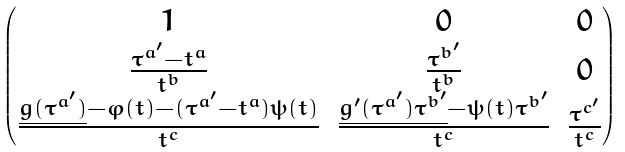Convert formula to latex. <formula><loc_0><loc_0><loc_500><loc_500>\begin{pmatrix} 1 & 0 & 0 \\ \frac { \tau ^ { a ^ { \prime } } - t ^ { a } } { t ^ { b } } & \frac { \tau ^ { b ^ { \prime } } } { t ^ { b } } & 0 \\ \frac { \underline { g ( \tau ^ { a ^ { \prime } } ) } - \varphi ( t ) - ( \tau ^ { a ^ { \prime } } - t ^ { a } ) \psi ( t ) } { t ^ { c } } & \frac { \underline { g ^ { \prime } ( \tau ^ { a ^ { \prime } } ) \tau ^ { b ^ { \prime } } } - \psi ( t ) \tau ^ { b ^ { \prime } } } { t ^ { c } } & \frac { \tau ^ { c ^ { \prime } } } { t ^ { c } } \end{pmatrix}</formula> 